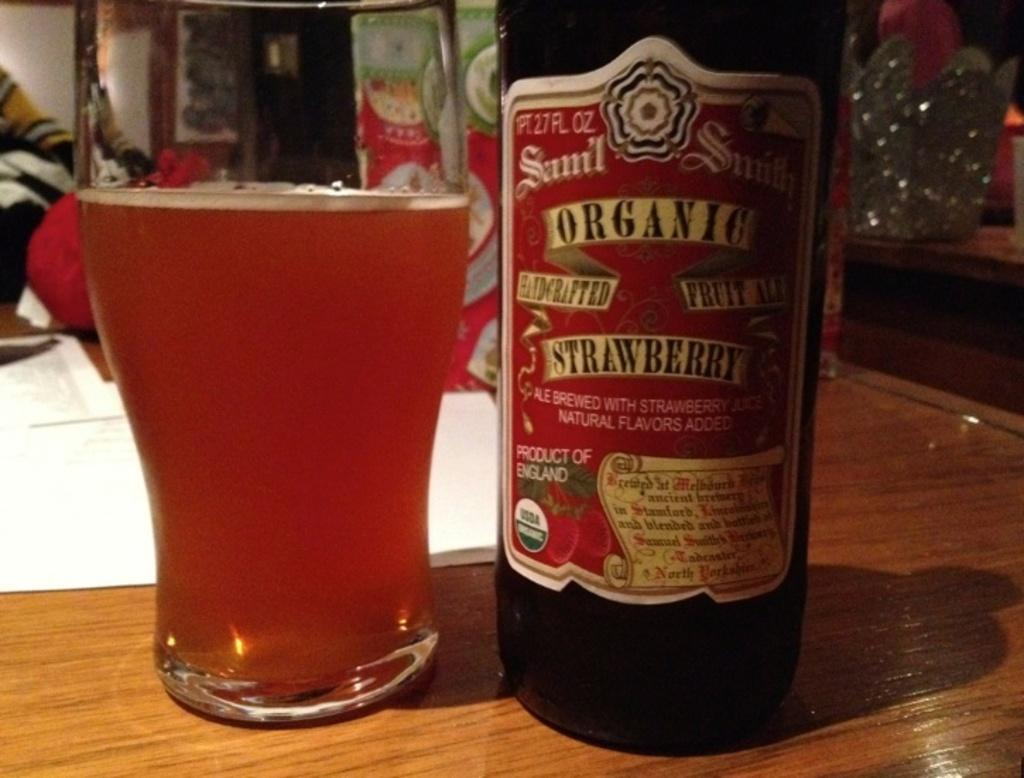<image>
Provide a brief description of the given image. A bottle of organic strawberry drink next to a glass 